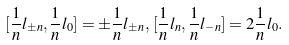Convert formula to latex. <formula><loc_0><loc_0><loc_500><loc_500>[ \frac { 1 } { n } l _ { \pm n } , \frac { 1 } { n } l _ { 0 } ] = \pm \frac { 1 } { n } l _ { \pm n } , \, [ \frac { 1 } { n } l _ { n } , \frac { 1 } { n } l _ { - n } ] = 2 \frac { 1 } { n } l _ { 0 } .</formula> 